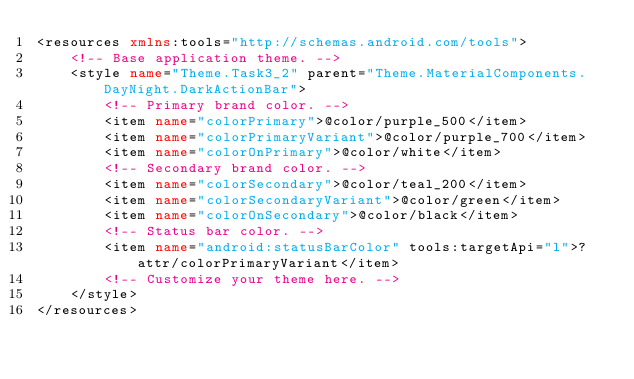<code> <loc_0><loc_0><loc_500><loc_500><_XML_><resources xmlns:tools="http://schemas.android.com/tools">
    <!-- Base application theme. -->
    <style name="Theme.Task3_2" parent="Theme.MaterialComponents.DayNight.DarkActionBar">
        <!-- Primary brand color. -->
        <item name="colorPrimary">@color/purple_500</item>
        <item name="colorPrimaryVariant">@color/purple_700</item>
        <item name="colorOnPrimary">@color/white</item>
        <!-- Secondary brand color. -->
        <item name="colorSecondary">@color/teal_200</item>
        <item name="colorSecondaryVariant">@color/green</item>
        <item name="colorOnSecondary">@color/black</item>
        <!-- Status bar color. -->
        <item name="android:statusBarColor" tools:targetApi="l">?attr/colorPrimaryVariant</item>
        <!-- Customize your theme here. -->
    </style>
</resources></code> 